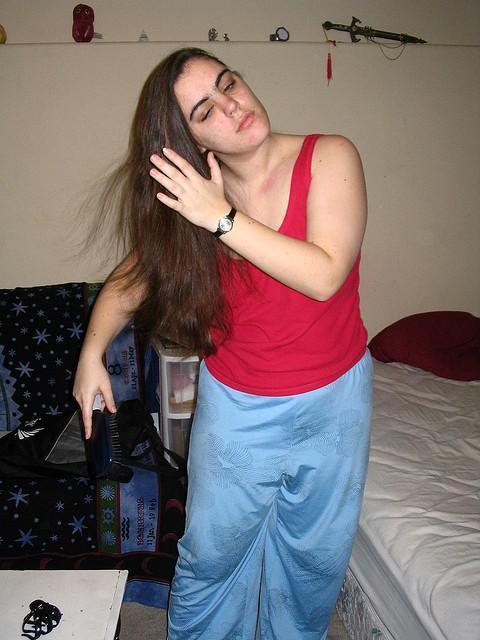How many couches are there?
Give a very brief answer. 1. How many buses are there going to max north?
Give a very brief answer. 0. 